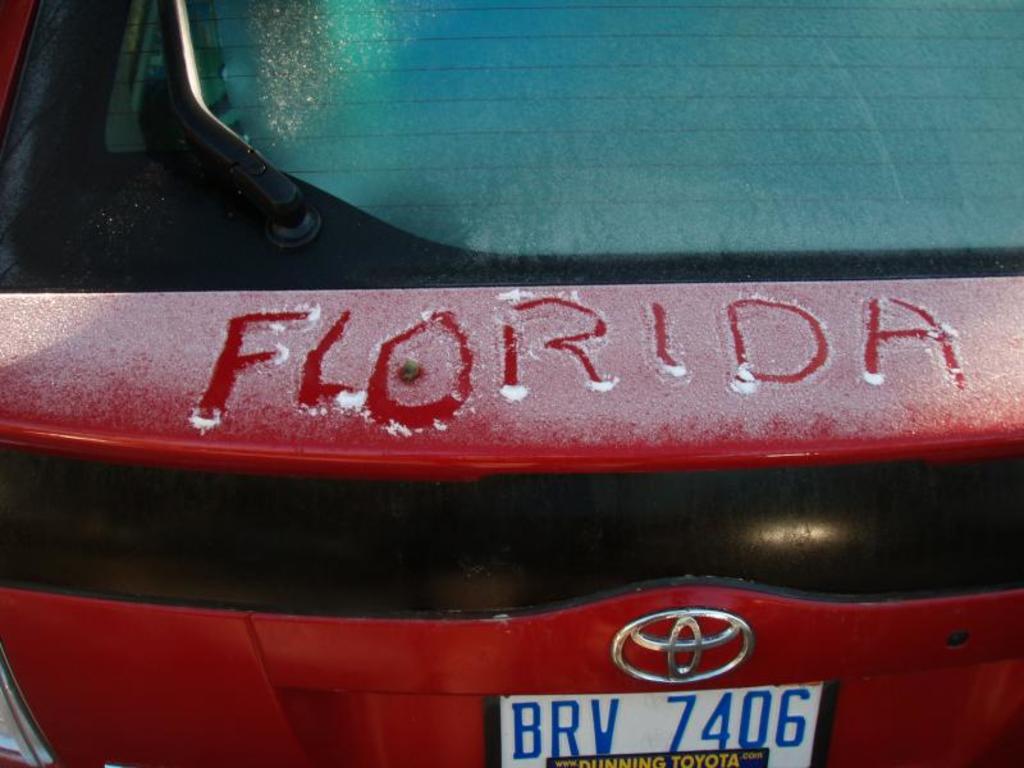What state has been scrawled into this bumper?
Keep it short and to the point. Florida. What kind of car is this?
Offer a terse response. Toyota. 